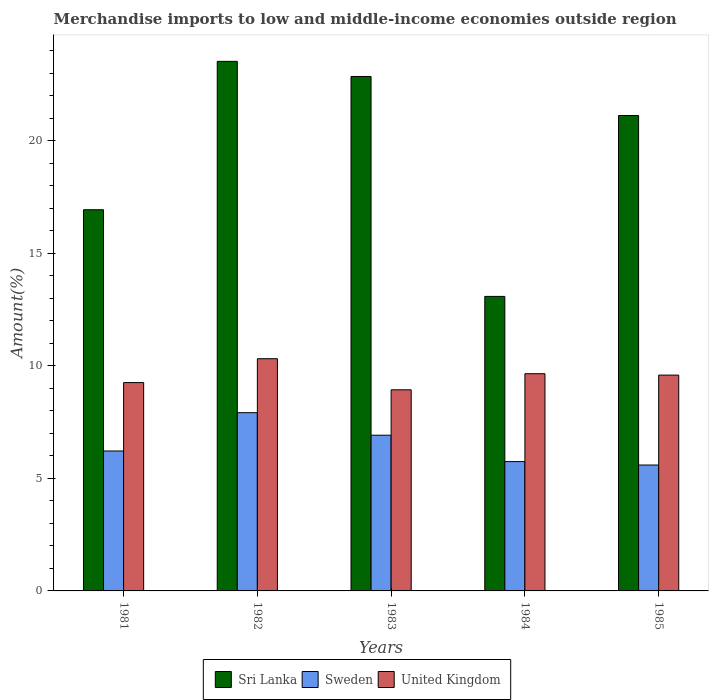How many groups of bars are there?
Ensure brevity in your answer.  5. How many bars are there on the 4th tick from the left?
Your answer should be very brief. 3. How many bars are there on the 5th tick from the right?
Ensure brevity in your answer.  3. In how many cases, is the number of bars for a given year not equal to the number of legend labels?
Keep it short and to the point. 0. What is the percentage of amount earned from merchandise imports in United Kingdom in 1984?
Make the answer very short. 9.65. Across all years, what is the maximum percentage of amount earned from merchandise imports in United Kingdom?
Offer a very short reply. 10.32. Across all years, what is the minimum percentage of amount earned from merchandise imports in Sri Lanka?
Keep it short and to the point. 13.09. What is the total percentage of amount earned from merchandise imports in Sri Lanka in the graph?
Offer a very short reply. 97.53. What is the difference between the percentage of amount earned from merchandise imports in Sri Lanka in 1982 and that in 1985?
Make the answer very short. 2.41. What is the difference between the percentage of amount earned from merchandise imports in Sri Lanka in 1983 and the percentage of amount earned from merchandise imports in United Kingdom in 1984?
Your answer should be very brief. 13.21. What is the average percentage of amount earned from merchandise imports in Sri Lanka per year?
Ensure brevity in your answer.  19.51. In the year 1983, what is the difference between the percentage of amount earned from merchandise imports in United Kingdom and percentage of amount earned from merchandise imports in Sri Lanka?
Make the answer very short. -13.92. What is the ratio of the percentage of amount earned from merchandise imports in Sri Lanka in 1981 to that in 1984?
Make the answer very short. 1.29. Is the percentage of amount earned from merchandise imports in Sri Lanka in 1984 less than that in 1985?
Your answer should be very brief. Yes. Is the difference between the percentage of amount earned from merchandise imports in United Kingdom in 1982 and 1985 greater than the difference between the percentage of amount earned from merchandise imports in Sri Lanka in 1982 and 1985?
Make the answer very short. No. What is the difference between the highest and the second highest percentage of amount earned from merchandise imports in United Kingdom?
Ensure brevity in your answer.  0.67. What is the difference between the highest and the lowest percentage of amount earned from merchandise imports in United Kingdom?
Make the answer very short. 1.38. What does the 2nd bar from the left in 1981 represents?
Offer a terse response. Sweden. What does the 3rd bar from the right in 1983 represents?
Your answer should be compact. Sri Lanka. How many bars are there?
Offer a very short reply. 15. Are all the bars in the graph horizontal?
Provide a succinct answer. No. Are the values on the major ticks of Y-axis written in scientific E-notation?
Provide a succinct answer. No. Does the graph contain grids?
Make the answer very short. No. What is the title of the graph?
Provide a short and direct response. Merchandise imports to low and middle-income economies outside region. Does "Kiribati" appear as one of the legend labels in the graph?
Provide a short and direct response. No. What is the label or title of the X-axis?
Your answer should be very brief. Years. What is the label or title of the Y-axis?
Your response must be concise. Amount(%). What is the Amount(%) of Sri Lanka in 1981?
Your answer should be very brief. 16.94. What is the Amount(%) in Sweden in 1981?
Your answer should be compact. 6.22. What is the Amount(%) of United Kingdom in 1981?
Make the answer very short. 9.26. What is the Amount(%) of Sri Lanka in 1982?
Offer a very short reply. 23.53. What is the Amount(%) in Sweden in 1982?
Offer a very short reply. 7.92. What is the Amount(%) of United Kingdom in 1982?
Keep it short and to the point. 10.32. What is the Amount(%) of Sri Lanka in 1983?
Provide a succinct answer. 22.86. What is the Amount(%) in Sweden in 1983?
Give a very brief answer. 6.92. What is the Amount(%) of United Kingdom in 1983?
Offer a very short reply. 8.94. What is the Amount(%) in Sri Lanka in 1984?
Give a very brief answer. 13.09. What is the Amount(%) of Sweden in 1984?
Your response must be concise. 5.75. What is the Amount(%) of United Kingdom in 1984?
Your response must be concise. 9.65. What is the Amount(%) of Sri Lanka in 1985?
Keep it short and to the point. 21.12. What is the Amount(%) in Sweden in 1985?
Offer a terse response. 5.59. What is the Amount(%) in United Kingdom in 1985?
Make the answer very short. 9.59. Across all years, what is the maximum Amount(%) in Sri Lanka?
Your answer should be compact. 23.53. Across all years, what is the maximum Amount(%) of Sweden?
Keep it short and to the point. 7.92. Across all years, what is the maximum Amount(%) in United Kingdom?
Make the answer very short. 10.32. Across all years, what is the minimum Amount(%) of Sri Lanka?
Offer a terse response. 13.09. Across all years, what is the minimum Amount(%) of Sweden?
Give a very brief answer. 5.59. Across all years, what is the minimum Amount(%) of United Kingdom?
Ensure brevity in your answer.  8.94. What is the total Amount(%) in Sri Lanka in the graph?
Make the answer very short. 97.53. What is the total Amount(%) in Sweden in the graph?
Your response must be concise. 32.4. What is the total Amount(%) of United Kingdom in the graph?
Make the answer very short. 47.75. What is the difference between the Amount(%) in Sri Lanka in 1981 and that in 1982?
Give a very brief answer. -6.59. What is the difference between the Amount(%) in Sweden in 1981 and that in 1982?
Your answer should be very brief. -1.7. What is the difference between the Amount(%) in United Kingdom in 1981 and that in 1982?
Offer a terse response. -1.06. What is the difference between the Amount(%) in Sri Lanka in 1981 and that in 1983?
Make the answer very short. -5.92. What is the difference between the Amount(%) in Sweden in 1981 and that in 1983?
Keep it short and to the point. -0.7. What is the difference between the Amount(%) of United Kingdom in 1981 and that in 1983?
Keep it short and to the point. 0.32. What is the difference between the Amount(%) of Sri Lanka in 1981 and that in 1984?
Make the answer very short. 3.85. What is the difference between the Amount(%) in Sweden in 1981 and that in 1984?
Your answer should be very brief. 0.47. What is the difference between the Amount(%) in United Kingdom in 1981 and that in 1984?
Your response must be concise. -0.39. What is the difference between the Amount(%) of Sri Lanka in 1981 and that in 1985?
Offer a terse response. -4.19. What is the difference between the Amount(%) in Sweden in 1981 and that in 1985?
Provide a succinct answer. 0.62. What is the difference between the Amount(%) in United Kingdom in 1981 and that in 1985?
Make the answer very short. -0.33. What is the difference between the Amount(%) of Sri Lanka in 1982 and that in 1983?
Make the answer very short. 0.67. What is the difference between the Amount(%) of United Kingdom in 1982 and that in 1983?
Offer a terse response. 1.38. What is the difference between the Amount(%) of Sri Lanka in 1982 and that in 1984?
Give a very brief answer. 10.44. What is the difference between the Amount(%) in Sweden in 1982 and that in 1984?
Offer a very short reply. 2.17. What is the difference between the Amount(%) in United Kingdom in 1982 and that in 1984?
Your response must be concise. 0.67. What is the difference between the Amount(%) of Sri Lanka in 1982 and that in 1985?
Provide a succinct answer. 2.41. What is the difference between the Amount(%) in Sweden in 1982 and that in 1985?
Your answer should be compact. 2.33. What is the difference between the Amount(%) of United Kingdom in 1982 and that in 1985?
Provide a succinct answer. 0.73. What is the difference between the Amount(%) of Sri Lanka in 1983 and that in 1984?
Ensure brevity in your answer.  9.77. What is the difference between the Amount(%) of Sweden in 1983 and that in 1984?
Your answer should be very brief. 1.17. What is the difference between the Amount(%) of United Kingdom in 1983 and that in 1984?
Keep it short and to the point. -0.71. What is the difference between the Amount(%) in Sri Lanka in 1983 and that in 1985?
Provide a short and direct response. 1.73. What is the difference between the Amount(%) in Sweden in 1983 and that in 1985?
Offer a terse response. 1.32. What is the difference between the Amount(%) in United Kingdom in 1983 and that in 1985?
Make the answer very short. -0.65. What is the difference between the Amount(%) of Sri Lanka in 1984 and that in 1985?
Your answer should be compact. -8.04. What is the difference between the Amount(%) in Sweden in 1984 and that in 1985?
Provide a succinct answer. 0.15. What is the difference between the Amount(%) of United Kingdom in 1984 and that in 1985?
Your answer should be very brief. 0.06. What is the difference between the Amount(%) in Sri Lanka in 1981 and the Amount(%) in Sweden in 1982?
Ensure brevity in your answer.  9.02. What is the difference between the Amount(%) of Sri Lanka in 1981 and the Amount(%) of United Kingdom in 1982?
Give a very brief answer. 6.62. What is the difference between the Amount(%) in Sweden in 1981 and the Amount(%) in United Kingdom in 1982?
Provide a succinct answer. -4.1. What is the difference between the Amount(%) of Sri Lanka in 1981 and the Amount(%) of Sweden in 1983?
Provide a succinct answer. 10.02. What is the difference between the Amount(%) in Sri Lanka in 1981 and the Amount(%) in United Kingdom in 1983?
Keep it short and to the point. 8. What is the difference between the Amount(%) in Sweden in 1981 and the Amount(%) in United Kingdom in 1983?
Your answer should be very brief. -2.72. What is the difference between the Amount(%) in Sri Lanka in 1981 and the Amount(%) in Sweden in 1984?
Provide a succinct answer. 11.19. What is the difference between the Amount(%) in Sri Lanka in 1981 and the Amount(%) in United Kingdom in 1984?
Give a very brief answer. 7.29. What is the difference between the Amount(%) in Sweden in 1981 and the Amount(%) in United Kingdom in 1984?
Ensure brevity in your answer.  -3.43. What is the difference between the Amount(%) of Sri Lanka in 1981 and the Amount(%) of Sweden in 1985?
Give a very brief answer. 11.34. What is the difference between the Amount(%) in Sri Lanka in 1981 and the Amount(%) in United Kingdom in 1985?
Offer a terse response. 7.35. What is the difference between the Amount(%) in Sweden in 1981 and the Amount(%) in United Kingdom in 1985?
Offer a very short reply. -3.37. What is the difference between the Amount(%) of Sri Lanka in 1982 and the Amount(%) of Sweden in 1983?
Offer a terse response. 16.61. What is the difference between the Amount(%) of Sri Lanka in 1982 and the Amount(%) of United Kingdom in 1983?
Provide a succinct answer. 14.59. What is the difference between the Amount(%) in Sweden in 1982 and the Amount(%) in United Kingdom in 1983?
Offer a very short reply. -1.02. What is the difference between the Amount(%) of Sri Lanka in 1982 and the Amount(%) of Sweden in 1984?
Offer a very short reply. 17.78. What is the difference between the Amount(%) in Sri Lanka in 1982 and the Amount(%) in United Kingdom in 1984?
Keep it short and to the point. 13.88. What is the difference between the Amount(%) of Sweden in 1982 and the Amount(%) of United Kingdom in 1984?
Ensure brevity in your answer.  -1.73. What is the difference between the Amount(%) of Sri Lanka in 1982 and the Amount(%) of Sweden in 1985?
Keep it short and to the point. 17.94. What is the difference between the Amount(%) in Sri Lanka in 1982 and the Amount(%) in United Kingdom in 1985?
Make the answer very short. 13.94. What is the difference between the Amount(%) of Sweden in 1982 and the Amount(%) of United Kingdom in 1985?
Your answer should be very brief. -1.67. What is the difference between the Amount(%) of Sri Lanka in 1983 and the Amount(%) of Sweden in 1984?
Give a very brief answer. 17.11. What is the difference between the Amount(%) of Sri Lanka in 1983 and the Amount(%) of United Kingdom in 1984?
Offer a very short reply. 13.21. What is the difference between the Amount(%) of Sweden in 1983 and the Amount(%) of United Kingdom in 1984?
Your answer should be very brief. -2.73. What is the difference between the Amount(%) in Sri Lanka in 1983 and the Amount(%) in Sweden in 1985?
Your response must be concise. 17.26. What is the difference between the Amount(%) in Sri Lanka in 1983 and the Amount(%) in United Kingdom in 1985?
Ensure brevity in your answer.  13.27. What is the difference between the Amount(%) in Sweden in 1983 and the Amount(%) in United Kingdom in 1985?
Ensure brevity in your answer.  -2.67. What is the difference between the Amount(%) of Sri Lanka in 1984 and the Amount(%) of Sweden in 1985?
Your answer should be very brief. 7.49. What is the difference between the Amount(%) in Sri Lanka in 1984 and the Amount(%) in United Kingdom in 1985?
Keep it short and to the point. 3.5. What is the difference between the Amount(%) of Sweden in 1984 and the Amount(%) of United Kingdom in 1985?
Your answer should be compact. -3.84. What is the average Amount(%) of Sri Lanka per year?
Provide a succinct answer. 19.51. What is the average Amount(%) in Sweden per year?
Make the answer very short. 6.48. What is the average Amount(%) of United Kingdom per year?
Ensure brevity in your answer.  9.55. In the year 1981, what is the difference between the Amount(%) in Sri Lanka and Amount(%) in Sweden?
Make the answer very short. 10.72. In the year 1981, what is the difference between the Amount(%) of Sri Lanka and Amount(%) of United Kingdom?
Your response must be concise. 7.68. In the year 1981, what is the difference between the Amount(%) of Sweden and Amount(%) of United Kingdom?
Your answer should be very brief. -3.04. In the year 1982, what is the difference between the Amount(%) in Sri Lanka and Amount(%) in Sweden?
Make the answer very short. 15.61. In the year 1982, what is the difference between the Amount(%) in Sri Lanka and Amount(%) in United Kingdom?
Your response must be concise. 13.21. In the year 1982, what is the difference between the Amount(%) of Sweden and Amount(%) of United Kingdom?
Your answer should be very brief. -2.4. In the year 1983, what is the difference between the Amount(%) of Sri Lanka and Amount(%) of Sweden?
Your response must be concise. 15.94. In the year 1983, what is the difference between the Amount(%) of Sri Lanka and Amount(%) of United Kingdom?
Offer a very short reply. 13.92. In the year 1983, what is the difference between the Amount(%) in Sweden and Amount(%) in United Kingdom?
Your answer should be compact. -2.02. In the year 1984, what is the difference between the Amount(%) in Sri Lanka and Amount(%) in Sweden?
Offer a terse response. 7.34. In the year 1984, what is the difference between the Amount(%) of Sri Lanka and Amount(%) of United Kingdom?
Your answer should be compact. 3.44. In the year 1984, what is the difference between the Amount(%) of Sweden and Amount(%) of United Kingdom?
Make the answer very short. -3.9. In the year 1985, what is the difference between the Amount(%) in Sri Lanka and Amount(%) in Sweden?
Give a very brief answer. 15.53. In the year 1985, what is the difference between the Amount(%) in Sri Lanka and Amount(%) in United Kingdom?
Your answer should be compact. 11.53. In the year 1985, what is the difference between the Amount(%) of Sweden and Amount(%) of United Kingdom?
Make the answer very short. -4. What is the ratio of the Amount(%) in Sri Lanka in 1981 to that in 1982?
Offer a terse response. 0.72. What is the ratio of the Amount(%) in Sweden in 1981 to that in 1982?
Offer a very short reply. 0.79. What is the ratio of the Amount(%) in United Kingdom in 1981 to that in 1982?
Make the answer very short. 0.9. What is the ratio of the Amount(%) in Sri Lanka in 1981 to that in 1983?
Provide a short and direct response. 0.74. What is the ratio of the Amount(%) in Sweden in 1981 to that in 1983?
Offer a very short reply. 0.9. What is the ratio of the Amount(%) in United Kingdom in 1981 to that in 1983?
Provide a succinct answer. 1.04. What is the ratio of the Amount(%) in Sri Lanka in 1981 to that in 1984?
Provide a succinct answer. 1.29. What is the ratio of the Amount(%) of Sweden in 1981 to that in 1984?
Provide a succinct answer. 1.08. What is the ratio of the Amount(%) in United Kingdom in 1981 to that in 1984?
Give a very brief answer. 0.96. What is the ratio of the Amount(%) of Sri Lanka in 1981 to that in 1985?
Provide a succinct answer. 0.8. What is the ratio of the Amount(%) of Sweden in 1981 to that in 1985?
Offer a very short reply. 1.11. What is the ratio of the Amount(%) in United Kingdom in 1981 to that in 1985?
Make the answer very short. 0.97. What is the ratio of the Amount(%) in Sri Lanka in 1982 to that in 1983?
Your response must be concise. 1.03. What is the ratio of the Amount(%) in Sweden in 1982 to that in 1983?
Give a very brief answer. 1.14. What is the ratio of the Amount(%) of United Kingdom in 1982 to that in 1983?
Your answer should be very brief. 1.15. What is the ratio of the Amount(%) in Sri Lanka in 1982 to that in 1984?
Provide a succinct answer. 1.8. What is the ratio of the Amount(%) of Sweden in 1982 to that in 1984?
Keep it short and to the point. 1.38. What is the ratio of the Amount(%) in United Kingdom in 1982 to that in 1984?
Make the answer very short. 1.07. What is the ratio of the Amount(%) in Sri Lanka in 1982 to that in 1985?
Make the answer very short. 1.11. What is the ratio of the Amount(%) of Sweden in 1982 to that in 1985?
Offer a very short reply. 1.42. What is the ratio of the Amount(%) of United Kingdom in 1982 to that in 1985?
Give a very brief answer. 1.08. What is the ratio of the Amount(%) in Sri Lanka in 1983 to that in 1984?
Your response must be concise. 1.75. What is the ratio of the Amount(%) in Sweden in 1983 to that in 1984?
Provide a succinct answer. 1.2. What is the ratio of the Amount(%) in United Kingdom in 1983 to that in 1984?
Your response must be concise. 0.93. What is the ratio of the Amount(%) in Sri Lanka in 1983 to that in 1985?
Give a very brief answer. 1.08. What is the ratio of the Amount(%) of Sweden in 1983 to that in 1985?
Give a very brief answer. 1.24. What is the ratio of the Amount(%) of United Kingdom in 1983 to that in 1985?
Offer a terse response. 0.93. What is the ratio of the Amount(%) in Sri Lanka in 1984 to that in 1985?
Your answer should be very brief. 0.62. What is the ratio of the Amount(%) of Sweden in 1984 to that in 1985?
Your answer should be very brief. 1.03. What is the ratio of the Amount(%) of United Kingdom in 1984 to that in 1985?
Provide a short and direct response. 1.01. What is the difference between the highest and the second highest Amount(%) of Sri Lanka?
Offer a very short reply. 0.67. What is the difference between the highest and the second highest Amount(%) of United Kingdom?
Ensure brevity in your answer.  0.67. What is the difference between the highest and the lowest Amount(%) in Sri Lanka?
Make the answer very short. 10.44. What is the difference between the highest and the lowest Amount(%) of Sweden?
Offer a very short reply. 2.33. What is the difference between the highest and the lowest Amount(%) of United Kingdom?
Ensure brevity in your answer.  1.38. 